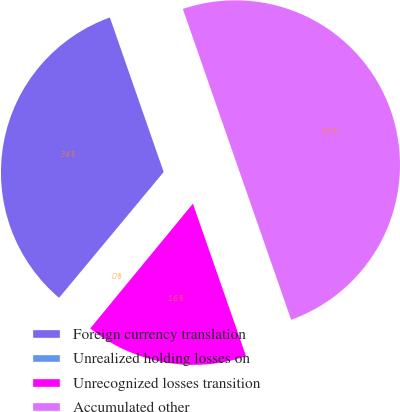<chart> <loc_0><loc_0><loc_500><loc_500><pie_chart><fcel>Foreign currency translation<fcel>Unrealized holding losses on<fcel>Unrecognized losses transition<fcel>Accumulated other<nl><fcel>33.63%<fcel>0.08%<fcel>16.3%<fcel>50.0%<nl></chart> 